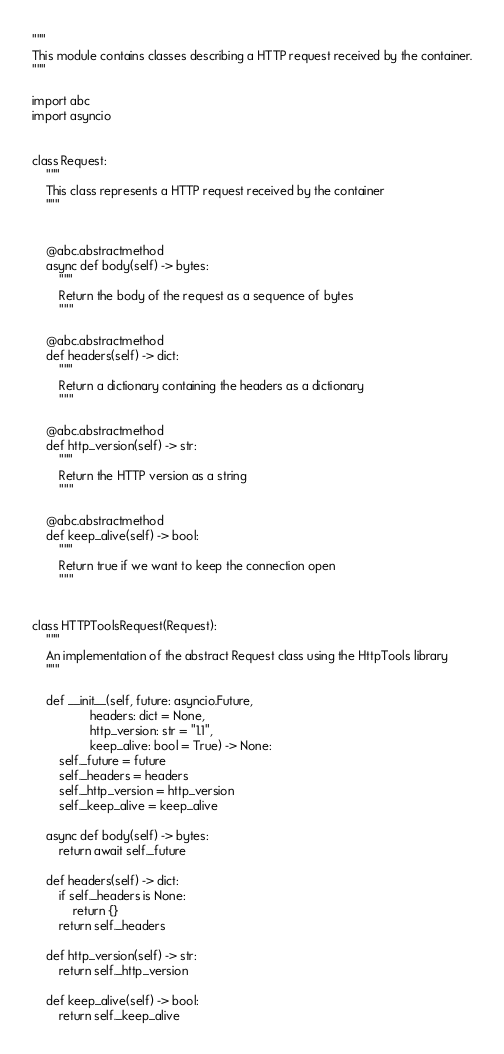<code> <loc_0><loc_0><loc_500><loc_500><_Python_>"""
This module contains classes describing a HTTP request received by the container.
"""

import abc
import asyncio


class Request:
    """
    This class represents a HTTP request received by the container
    """


    @abc.abstractmethod
    async def body(self) -> bytes:
        """
        Return the body of the request as a sequence of bytes
        """

    @abc.abstractmethod
    def headers(self) -> dict:
        """
        Return a dictionary containing the headers as a dictionary
        """

    @abc.abstractmethod
    def http_version(self) -> str:
        """
        Return the HTTP version as a string
        """

    @abc.abstractmethod
    def keep_alive(self) -> bool:
        """
        Return true if we want to keep the connection open
        """


class HTTPToolsRequest(Request):
    """
    An implementation of the abstract Request class using the HttpTools library
    """

    def __init__(self, future: asyncio.Future,
                 headers: dict = None,
                 http_version: str = "1.1",
                 keep_alive: bool = True) -> None:
        self._future = future
        self._headers = headers
        self._http_version = http_version
        self._keep_alive = keep_alive

    async def body(self) -> bytes:
        return await self._future

    def headers(self) -> dict:
        if self._headers is None:
            return {}
        return self._headers

    def http_version(self) -> str:
        return self._http_version

    def keep_alive(self) -> bool:
        return self._keep_alive
</code> 